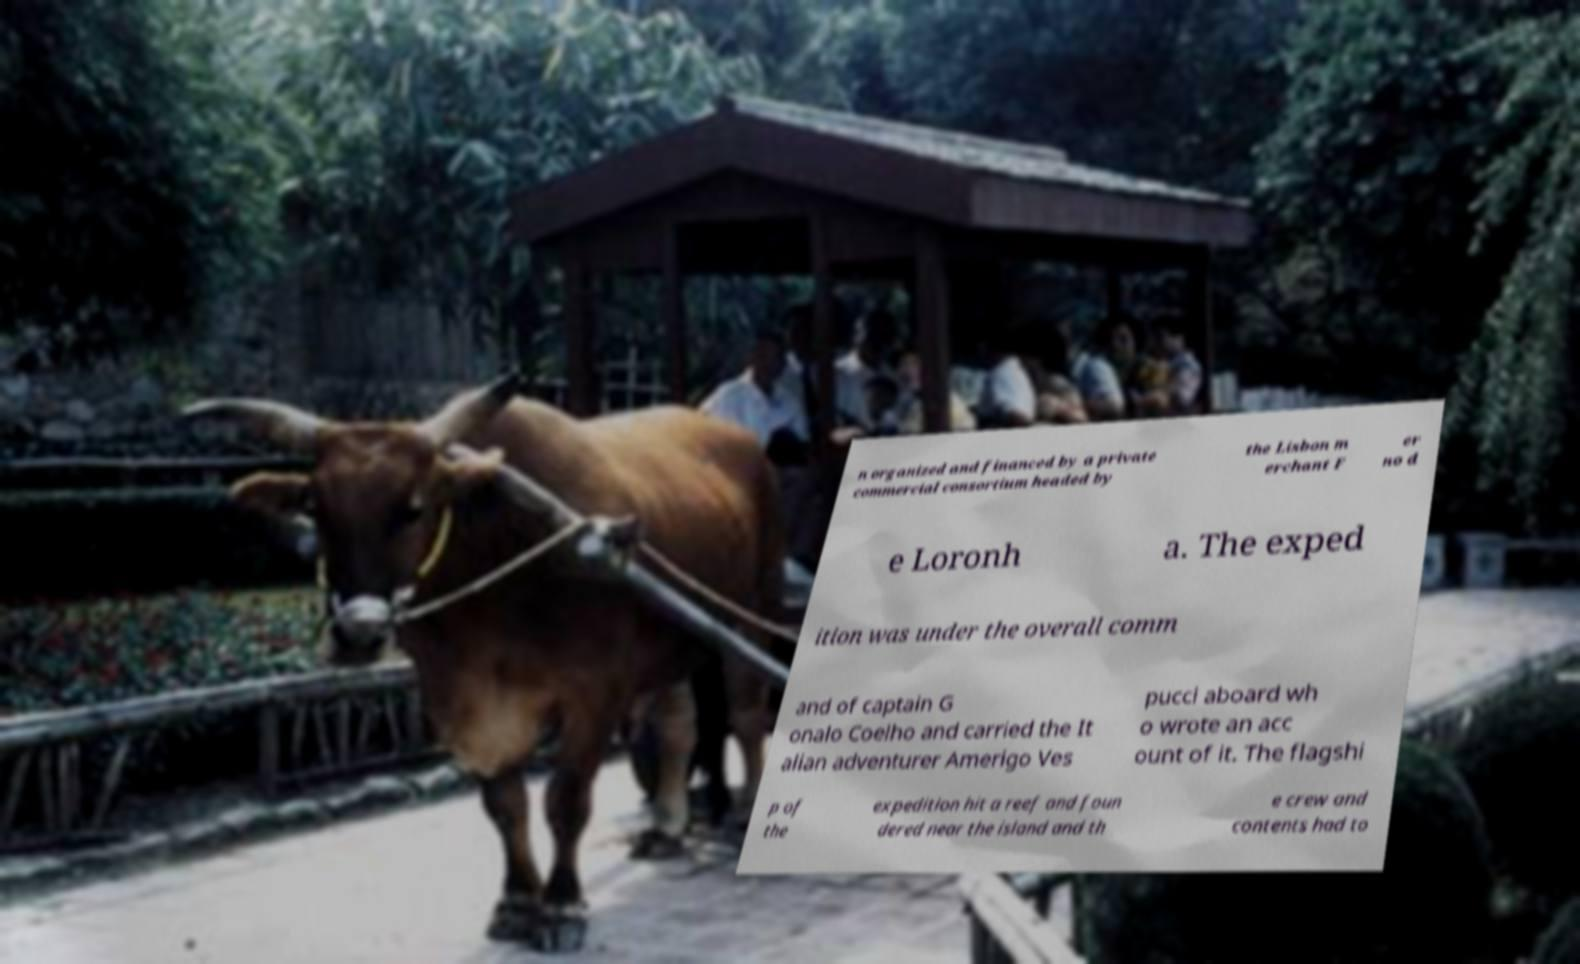For documentation purposes, I need the text within this image transcribed. Could you provide that? n organized and financed by a private commercial consortium headed by the Lisbon m erchant F er no d e Loronh a. The exped ition was under the overall comm and of captain G onalo Coelho and carried the It alian adventurer Amerigo Ves pucci aboard wh o wrote an acc ount of it. The flagshi p of the expedition hit a reef and foun dered near the island and th e crew and contents had to 